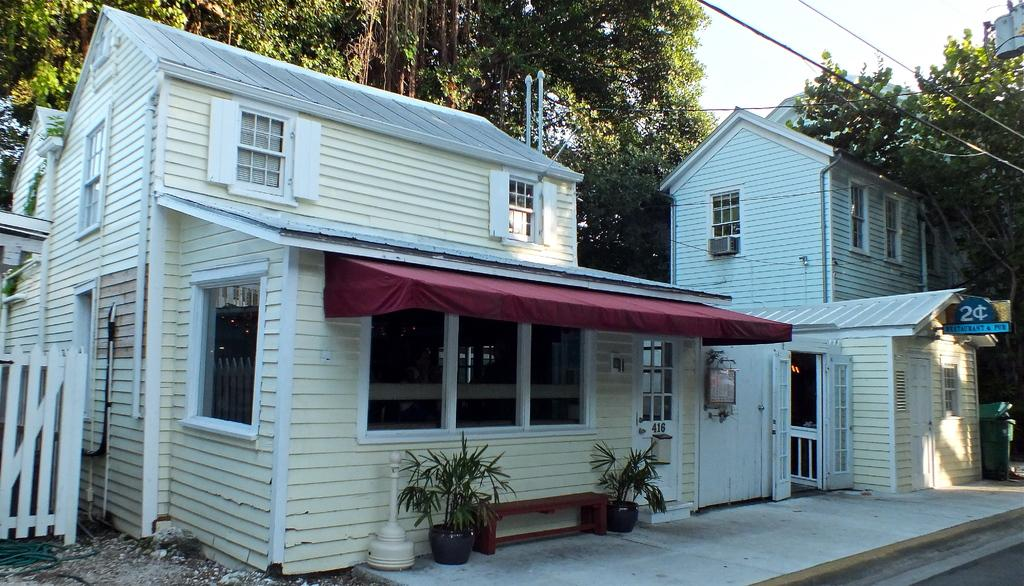What is the main structure in the foreground of the image? There is a house in the foreground of the image. What feature can be seen on the house in the image? There is a canopy to a window in the foreground. What type of vegetation is present in the image? Potted plants are visible in the image. What type of entrance is present in the image? The gates are present in the image. What is visible at the top of the image? The sky is visible at the top of the image. What type of metal skate is being used to clean the soap off the house in the image? There is no metal skate or soap present in the image. The house is not being cleaned in the image. 